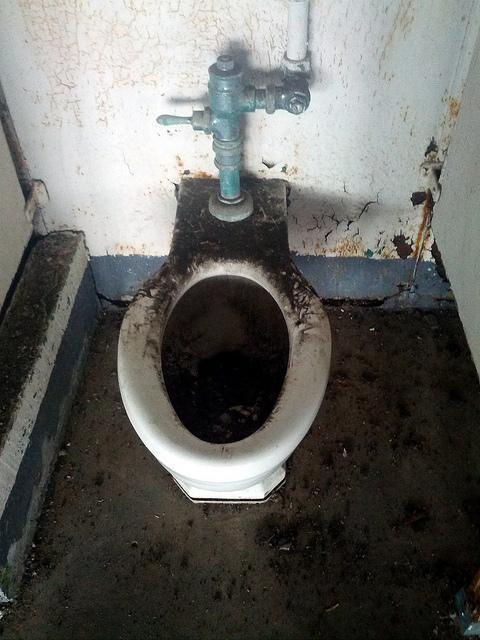How many people are wearing a red shirt?
Give a very brief answer. 0. 